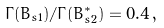Convert formula to latex. <formula><loc_0><loc_0><loc_500><loc_500>\Gamma ( B _ { s 1 } ) / \Gamma ( B _ { s 2 } ^ { * } ) = 0 . 4 \, ,</formula> 